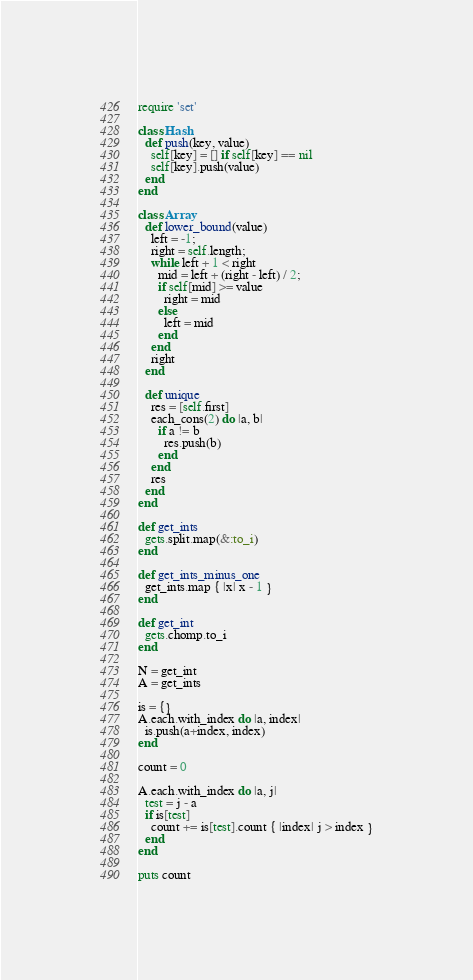Convert code to text. <code><loc_0><loc_0><loc_500><loc_500><_Ruby_>require 'set'

class Hash
  def push(key, value)
    self[key] = [] if self[key] == nil
    self[key].push(value)
  end
end

class Array
  def lower_bound(value)
    left = -1;
    right = self.length;
    while left + 1 < right
      mid = left + (right - left) / 2;
      if self[mid] >= value
        right = mid
      else
        left = mid
      end
    end
    right
  end

  def unique
    res = [self.first]
    each_cons(2) do |a, b|
      if a != b
        res.push(b)
      end
    end
    res
  end
end

def get_ints
  gets.split.map(&:to_i)
end

def get_ints_minus_one
  get_ints.map { |x| x - 1 }
end

def get_int
  gets.chomp.to_i
end

N = get_int
A = get_ints

is = {}
A.each.with_index do |a, index|
  is.push(a+index, index)
end

count = 0

A.each.with_index do |a, j|
  test = j - a
  if is[test]
    count += is[test].count { |index| j > index }
  end
end

puts count
</code> 